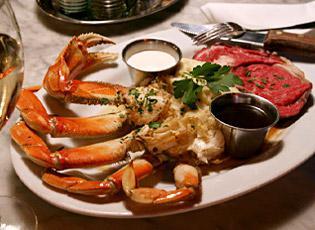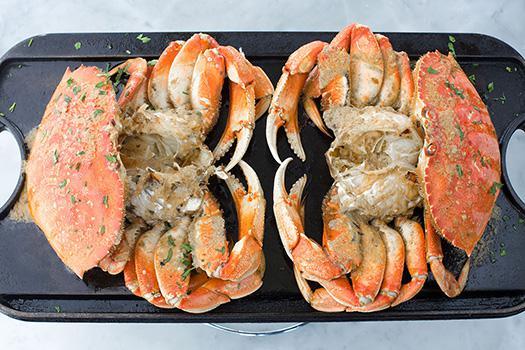The first image is the image on the left, the second image is the image on the right. Assess this claim about the two images: "there is a meal of crab on a plate with two silver bowls with condiments in them". Correct or not? Answer yes or no. Yes. 